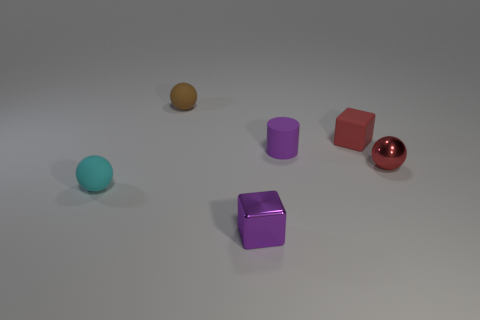Add 4 rubber cylinders. How many objects exist? 10 Subtract all blocks. How many objects are left? 4 Subtract 1 purple cylinders. How many objects are left? 5 Subtract all large blue matte cubes. Subtract all small brown matte objects. How many objects are left? 5 Add 5 brown matte things. How many brown matte things are left? 6 Add 1 tiny purple matte cylinders. How many tiny purple matte cylinders exist? 2 